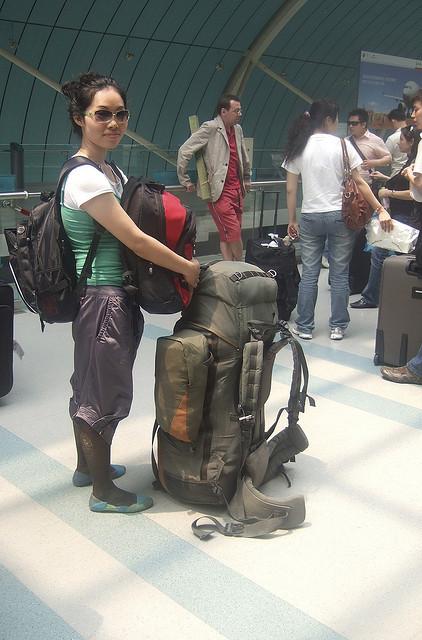Are the people going on a trip?
Quick response, please. Yes. What are the people standing on?
Be succinct. Floor. Where are the glasses?
Concise answer only. On her face. 